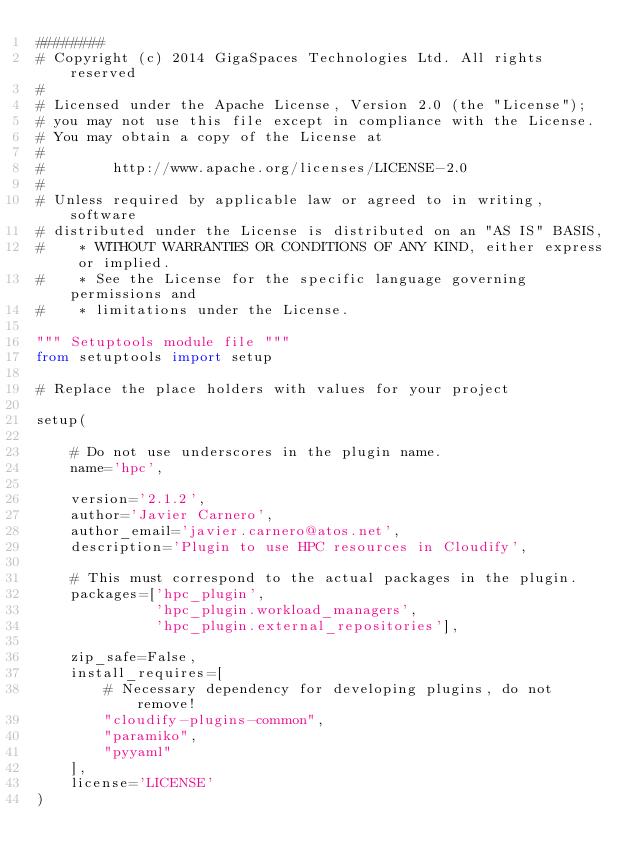<code> <loc_0><loc_0><loc_500><loc_500><_Python_>########
# Copyright (c) 2014 GigaSpaces Technologies Ltd. All rights reserved
#
# Licensed under the Apache License, Version 2.0 (the "License");
# you may not use this file except in compliance with the License.
# You may obtain a copy of the License at
#
#        http://www.apache.org/licenses/LICENSE-2.0
#
# Unless required by applicable law or agreed to in writing, software
# distributed under the License is distributed on an "AS IS" BASIS,
#    * WITHOUT WARRANTIES OR CONDITIONS OF ANY KIND, either express or implied.
#    * See the License for the specific language governing permissions and
#    * limitations under the License.

""" Setuptools module file """
from setuptools import setup

# Replace the place holders with values for your project

setup(

    # Do not use underscores in the plugin name.
    name='hpc',

    version='2.1.2',
    author='Javier Carnero',
    author_email='javier.carnero@atos.net',
    description='Plugin to use HPC resources in Cloudify',

    # This must correspond to the actual packages in the plugin.
    packages=['hpc_plugin',
              'hpc_plugin.workload_managers',
              'hpc_plugin.external_repositories'],

    zip_safe=False,
    install_requires=[
        # Necessary dependency for developing plugins, do not remove!
        "cloudify-plugins-common",
        "paramiko",
        "pyyaml"
    ],
    license='LICENSE'
)
</code> 